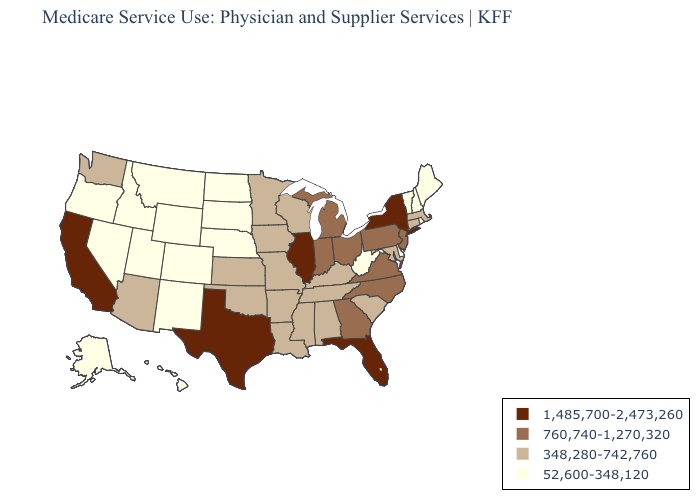Does Florida have the lowest value in the USA?
Write a very short answer. No. What is the lowest value in states that border Tennessee?
Keep it brief. 348,280-742,760. Name the states that have a value in the range 760,740-1,270,320?
Keep it brief. Georgia, Indiana, Michigan, New Jersey, North Carolina, Ohio, Pennsylvania, Virginia. What is the highest value in the MidWest ?
Be succinct. 1,485,700-2,473,260. How many symbols are there in the legend?
Quick response, please. 4. What is the value of Georgia?
Short answer required. 760,740-1,270,320. What is the value of Iowa?
Keep it brief. 348,280-742,760. What is the value of Washington?
Keep it brief. 348,280-742,760. How many symbols are there in the legend?
Short answer required. 4. Name the states that have a value in the range 52,600-348,120?
Be succinct. Alaska, Colorado, Delaware, Hawaii, Idaho, Maine, Montana, Nebraska, Nevada, New Hampshire, New Mexico, North Dakota, Oregon, Rhode Island, South Dakota, Utah, Vermont, West Virginia, Wyoming. What is the lowest value in the USA?
Write a very short answer. 52,600-348,120. What is the value of Indiana?
Short answer required. 760,740-1,270,320. Name the states that have a value in the range 760,740-1,270,320?
Give a very brief answer. Georgia, Indiana, Michigan, New Jersey, North Carolina, Ohio, Pennsylvania, Virginia. Name the states that have a value in the range 52,600-348,120?
Keep it brief. Alaska, Colorado, Delaware, Hawaii, Idaho, Maine, Montana, Nebraska, Nevada, New Hampshire, New Mexico, North Dakota, Oregon, Rhode Island, South Dakota, Utah, Vermont, West Virginia, Wyoming. Name the states that have a value in the range 1,485,700-2,473,260?
Keep it brief. California, Florida, Illinois, New York, Texas. 